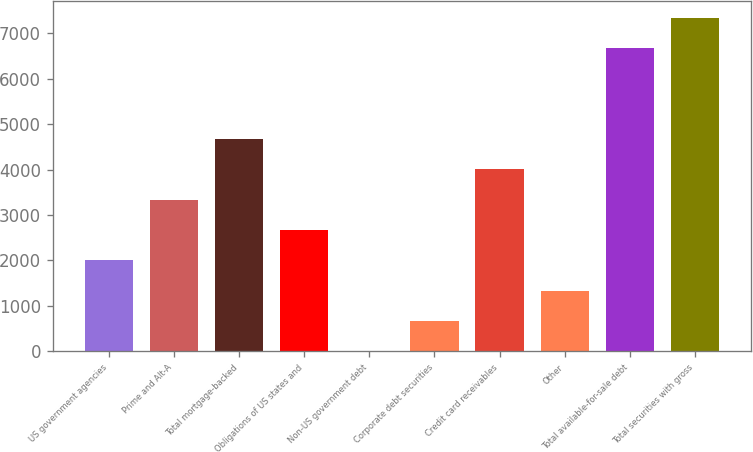<chart> <loc_0><loc_0><loc_500><loc_500><bar_chart><fcel>US government agencies<fcel>Prime and Alt-A<fcel>Total mortgage-backed<fcel>Obligations of US states and<fcel>Non-US government debt<fcel>Corporate debt securities<fcel>Credit card receivables<fcel>Other<fcel>Total available-for-sale debt<fcel>Total securities with gross<nl><fcel>2006.3<fcel>3342.5<fcel>4678.7<fcel>2674.4<fcel>2<fcel>670.1<fcel>4010.6<fcel>1338.2<fcel>6676<fcel>7344.1<nl></chart> 